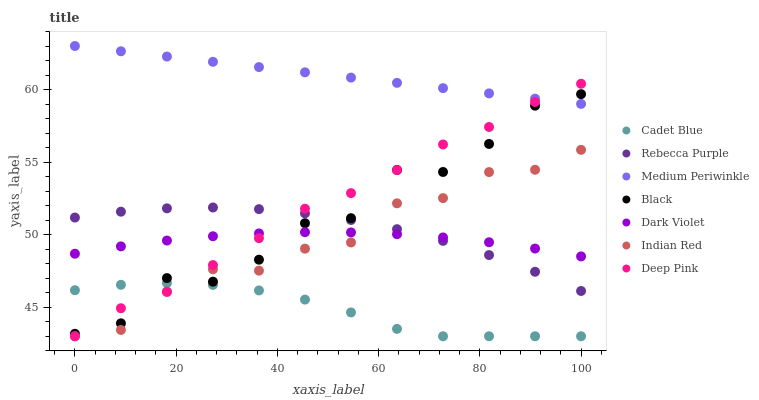Does Cadet Blue have the minimum area under the curve?
Answer yes or no. Yes. Does Medium Periwinkle have the maximum area under the curve?
Answer yes or no. Yes. Does Dark Violet have the minimum area under the curve?
Answer yes or no. No. Does Dark Violet have the maximum area under the curve?
Answer yes or no. No. Is Medium Periwinkle the smoothest?
Answer yes or no. Yes. Is Black the roughest?
Answer yes or no. Yes. Is Dark Violet the smoothest?
Answer yes or no. No. Is Dark Violet the roughest?
Answer yes or no. No. Does Cadet Blue have the lowest value?
Answer yes or no. Yes. Does Dark Violet have the lowest value?
Answer yes or no. No. Does Medium Periwinkle have the highest value?
Answer yes or no. Yes. Does Dark Violet have the highest value?
Answer yes or no. No. Is Cadet Blue less than Rebecca Purple?
Answer yes or no. Yes. Is Medium Periwinkle greater than Dark Violet?
Answer yes or no. Yes. Does Rebecca Purple intersect Dark Violet?
Answer yes or no. Yes. Is Rebecca Purple less than Dark Violet?
Answer yes or no. No. Is Rebecca Purple greater than Dark Violet?
Answer yes or no. No. Does Cadet Blue intersect Rebecca Purple?
Answer yes or no. No. 